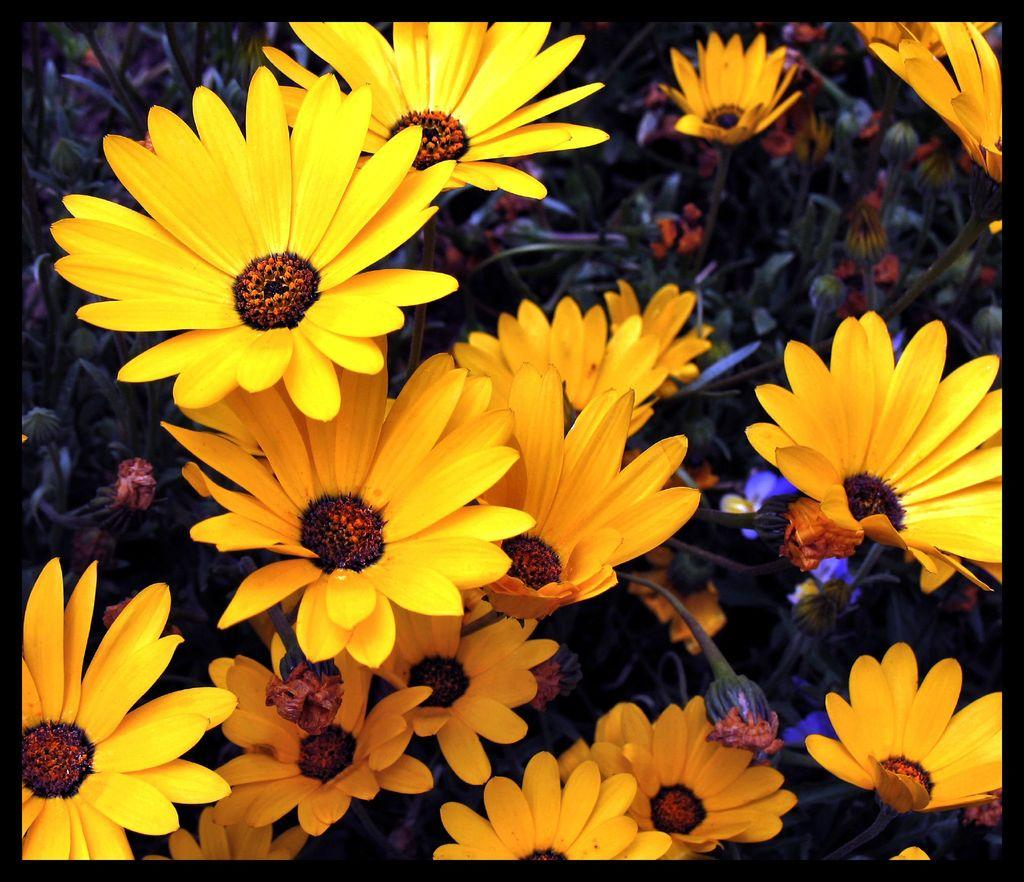What type of plants are in the image? There are flowers in the image. What color are the flowers? The flowers are yellow in color. What else can be seen in the background of the image? There are leaves in the background of the image. What is the price of the woman's system in the image? There is no woman or system present in the image; it features yellow flowers and leaves in the background. 